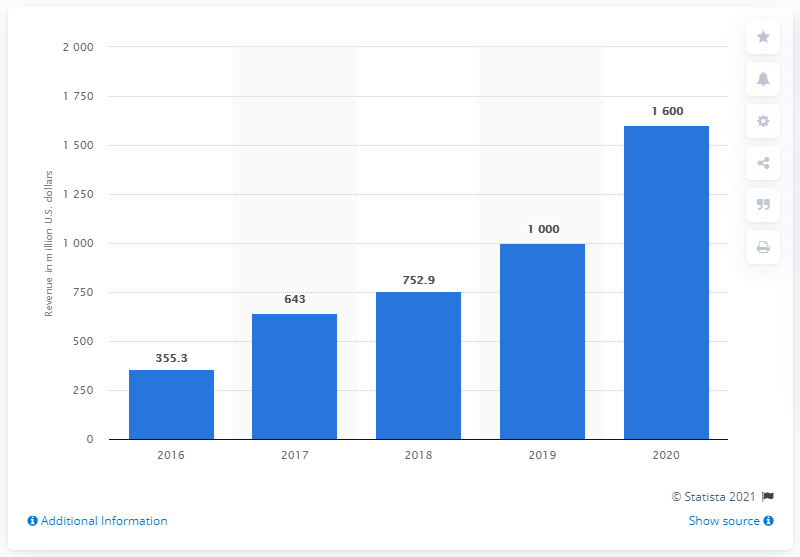Give some essential details in this illustration. In the United States in 2020, Snapchat's social networking revenue was approximately 1600. 